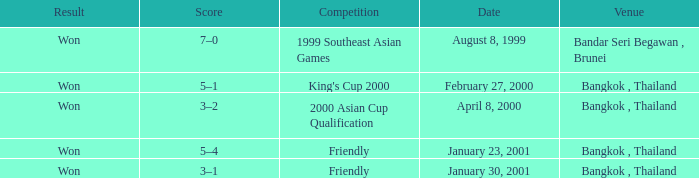What was the score from the king's cup 2000? 5–1. 